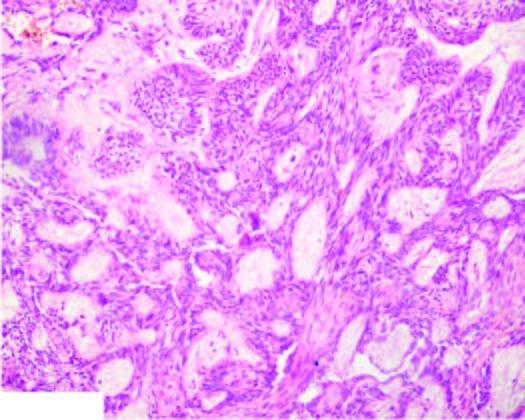what show central cystic change?
Answer the question using a single word or phrase. A few areas 